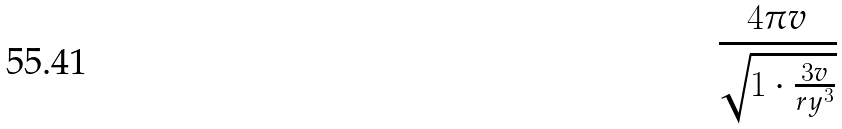Convert formula to latex. <formula><loc_0><loc_0><loc_500><loc_500>\frac { 4 \pi v } { \sqrt { 1 \cdot \frac { 3 v } { r y ^ { 3 } } } }</formula> 